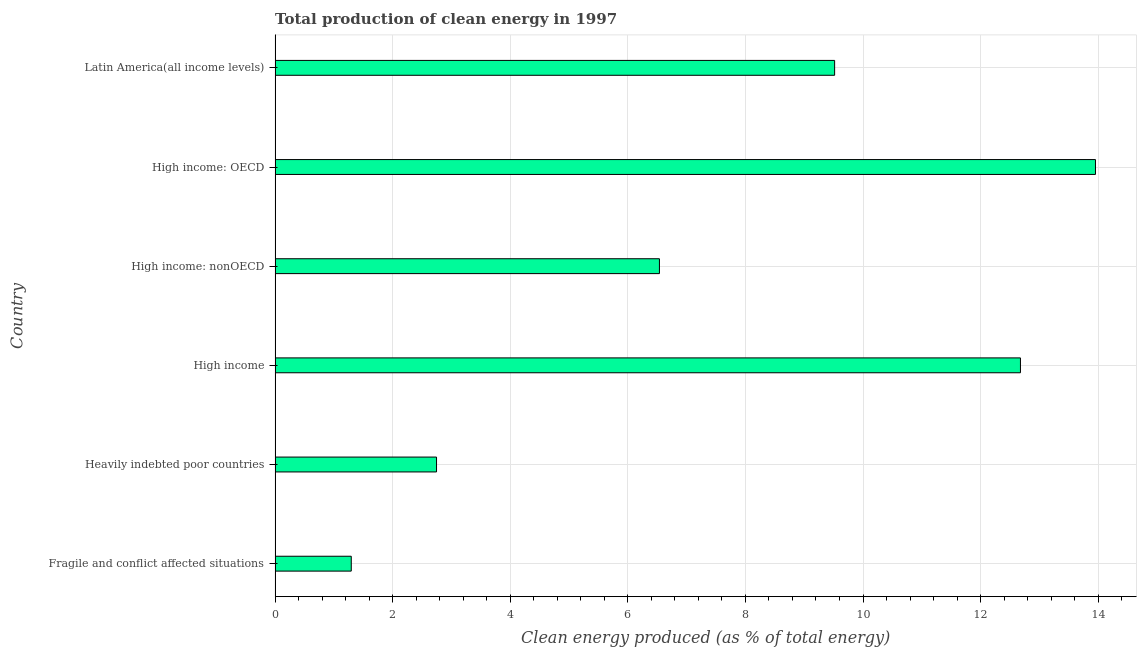Does the graph contain any zero values?
Offer a terse response. No. What is the title of the graph?
Your answer should be compact. Total production of clean energy in 1997. What is the label or title of the X-axis?
Offer a terse response. Clean energy produced (as % of total energy). What is the production of clean energy in High income: nonOECD?
Ensure brevity in your answer.  6.54. Across all countries, what is the maximum production of clean energy?
Provide a succinct answer. 13.95. Across all countries, what is the minimum production of clean energy?
Offer a terse response. 1.3. In which country was the production of clean energy maximum?
Provide a succinct answer. High income: OECD. In which country was the production of clean energy minimum?
Ensure brevity in your answer.  Fragile and conflict affected situations. What is the sum of the production of clean energy?
Provide a short and direct response. 46.73. What is the difference between the production of clean energy in High income and Latin America(all income levels)?
Offer a very short reply. 3.16. What is the average production of clean energy per country?
Make the answer very short. 7.79. What is the median production of clean energy?
Your answer should be compact. 8.03. What is the ratio of the production of clean energy in Fragile and conflict affected situations to that in Latin America(all income levels)?
Offer a terse response. 0.14. What is the difference between the highest and the second highest production of clean energy?
Provide a succinct answer. 1.28. What is the difference between the highest and the lowest production of clean energy?
Your response must be concise. 12.66. Are all the bars in the graph horizontal?
Offer a very short reply. Yes. What is the Clean energy produced (as % of total energy) in Fragile and conflict affected situations?
Offer a very short reply. 1.3. What is the Clean energy produced (as % of total energy) in Heavily indebted poor countries?
Provide a succinct answer. 2.75. What is the Clean energy produced (as % of total energy) of High income?
Your answer should be compact. 12.68. What is the Clean energy produced (as % of total energy) of High income: nonOECD?
Your answer should be very brief. 6.54. What is the Clean energy produced (as % of total energy) of High income: OECD?
Provide a short and direct response. 13.95. What is the Clean energy produced (as % of total energy) of Latin America(all income levels)?
Your answer should be very brief. 9.52. What is the difference between the Clean energy produced (as % of total energy) in Fragile and conflict affected situations and Heavily indebted poor countries?
Your answer should be compact. -1.45. What is the difference between the Clean energy produced (as % of total energy) in Fragile and conflict affected situations and High income?
Ensure brevity in your answer.  -11.38. What is the difference between the Clean energy produced (as % of total energy) in Fragile and conflict affected situations and High income: nonOECD?
Your answer should be compact. -5.24. What is the difference between the Clean energy produced (as % of total energy) in Fragile and conflict affected situations and High income: OECD?
Keep it short and to the point. -12.66. What is the difference between the Clean energy produced (as % of total energy) in Fragile and conflict affected situations and Latin America(all income levels)?
Provide a short and direct response. -8.22. What is the difference between the Clean energy produced (as % of total energy) in Heavily indebted poor countries and High income?
Keep it short and to the point. -9.93. What is the difference between the Clean energy produced (as % of total energy) in Heavily indebted poor countries and High income: nonOECD?
Give a very brief answer. -3.79. What is the difference between the Clean energy produced (as % of total energy) in Heavily indebted poor countries and High income: OECD?
Keep it short and to the point. -11.21. What is the difference between the Clean energy produced (as % of total energy) in Heavily indebted poor countries and Latin America(all income levels)?
Offer a terse response. -6.77. What is the difference between the Clean energy produced (as % of total energy) in High income and High income: nonOECD?
Your answer should be compact. 6.14. What is the difference between the Clean energy produced (as % of total energy) in High income and High income: OECD?
Your response must be concise. -1.28. What is the difference between the Clean energy produced (as % of total energy) in High income and Latin America(all income levels)?
Your response must be concise. 3.16. What is the difference between the Clean energy produced (as % of total energy) in High income: nonOECD and High income: OECD?
Keep it short and to the point. -7.42. What is the difference between the Clean energy produced (as % of total energy) in High income: nonOECD and Latin America(all income levels)?
Ensure brevity in your answer.  -2.98. What is the difference between the Clean energy produced (as % of total energy) in High income: OECD and Latin America(all income levels)?
Offer a very short reply. 4.44. What is the ratio of the Clean energy produced (as % of total energy) in Fragile and conflict affected situations to that in Heavily indebted poor countries?
Your answer should be very brief. 0.47. What is the ratio of the Clean energy produced (as % of total energy) in Fragile and conflict affected situations to that in High income?
Offer a very short reply. 0.1. What is the ratio of the Clean energy produced (as % of total energy) in Fragile and conflict affected situations to that in High income: nonOECD?
Make the answer very short. 0.2. What is the ratio of the Clean energy produced (as % of total energy) in Fragile and conflict affected situations to that in High income: OECD?
Keep it short and to the point. 0.09. What is the ratio of the Clean energy produced (as % of total energy) in Fragile and conflict affected situations to that in Latin America(all income levels)?
Make the answer very short. 0.14. What is the ratio of the Clean energy produced (as % of total energy) in Heavily indebted poor countries to that in High income?
Ensure brevity in your answer.  0.22. What is the ratio of the Clean energy produced (as % of total energy) in Heavily indebted poor countries to that in High income: nonOECD?
Your response must be concise. 0.42. What is the ratio of the Clean energy produced (as % of total energy) in Heavily indebted poor countries to that in High income: OECD?
Keep it short and to the point. 0.2. What is the ratio of the Clean energy produced (as % of total energy) in Heavily indebted poor countries to that in Latin America(all income levels)?
Ensure brevity in your answer.  0.29. What is the ratio of the Clean energy produced (as % of total energy) in High income to that in High income: nonOECD?
Make the answer very short. 1.94. What is the ratio of the Clean energy produced (as % of total energy) in High income to that in High income: OECD?
Give a very brief answer. 0.91. What is the ratio of the Clean energy produced (as % of total energy) in High income to that in Latin America(all income levels)?
Your answer should be compact. 1.33. What is the ratio of the Clean energy produced (as % of total energy) in High income: nonOECD to that in High income: OECD?
Your answer should be very brief. 0.47. What is the ratio of the Clean energy produced (as % of total energy) in High income: nonOECD to that in Latin America(all income levels)?
Provide a short and direct response. 0.69. What is the ratio of the Clean energy produced (as % of total energy) in High income: OECD to that in Latin America(all income levels)?
Offer a very short reply. 1.47. 